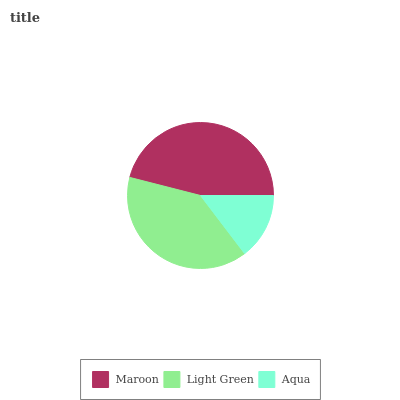Is Aqua the minimum?
Answer yes or no. Yes. Is Maroon the maximum?
Answer yes or no. Yes. Is Light Green the minimum?
Answer yes or no. No. Is Light Green the maximum?
Answer yes or no. No. Is Maroon greater than Light Green?
Answer yes or no. Yes. Is Light Green less than Maroon?
Answer yes or no. Yes. Is Light Green greater than Maroon?
Answer yes or no. No. Is Maroon less than Light Green?
Answer yes or no. No. Is Light Green the high median?
Answer yes or no. Yes. Is Light Green the low median?
Answer yes or no. Yes. Is Aqua the high median?
Answer yes or no. No. Is Aqua the low median?
Answer yes or no. No. 